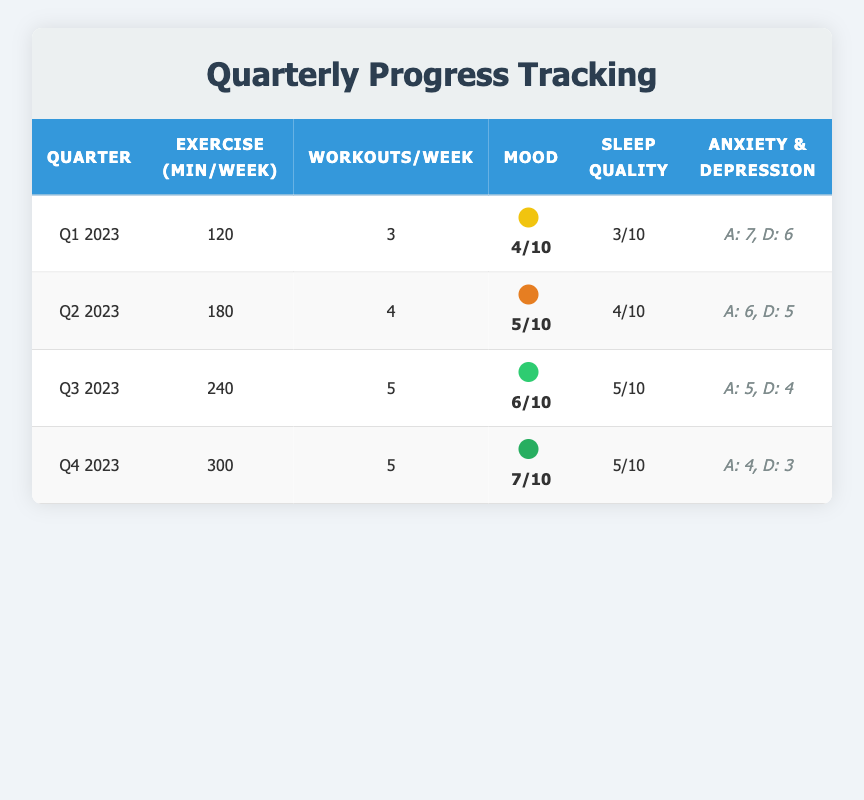What was the total number of exercise minutes recorded in Q3 2023? The table indicates that in Q3 2023, the exercise minutes were recorded as 240.
Answer: 240 How many workouts per week were done in Q1 2023? From the table, it shows that in Q1 2023, the workouts per week were recorded as 3.
Answer: 3 What is the change in average mood rating from Q1 to Q4 2023? In Q1 2023, the average mood rating was 4, and in Q4 2023, it was 7. The change is calculated as 7 - 4 = 3.
Answer: 3 Did the anxiety level decrease from Q1 2023 to Q4 2023? The anxiety level in Q1 2023 was 7, and in Q4 2023, it was 4. Since 4 is less than 7, the anxiety level did decrease.
Answer: Yes What is the average sleep quality rating across all quarters? The sleep quality ratings are 3, 4, 5, and 5 for Q1, Q2, Q3, and Q4 respectively. Sum them: 3 + 4 + 5 + 5 = 17. There are 4 quarters, so the average is 17/4 = 4.25.
Answer: 4.25 Which quarter had the highest recorded exercise minutes and what was that value? The highest exercise minutes are recorded in Q4 2023 with a value of 300 minutes, higher than other quarters.
Answer: Q4 2023: 300 How many total workouts were completed in Q2 and Q3 combined? In Q2 2023, there were 4 workouts per week, and in Q3 2023 there were 5 workouts per week. Assuming each quarter has approximately 13 weeks, the total workouts are (4 workouts/week * 13 weeks) + (5 workouts/week * 13 weeks) = 52 + 65 = 117.
Answer: 117 Was there an improvement in sleep quality from Q1 to Q3 2023? In Q1 2023, the sleep quality rating was 3, and in Q3 2023, it was 5. Since 5 is greater than 3, it indicates an improvement in sleep quality.
Answer: Yes What is the relationship between exercise minutes and average mood rating from Q2 to Q4 2023? In Q2 2023, exercise minutes were 180 with a mood rating of 5; in Q3, they were 240 with a rating of 6; in Q4, they were 300 with a rating of 7. The trend shows that as exercise minutes increase, the average mood rating also increases: (180 mins, 5) → (240 mins, 6) → (300 mins, 7).
Answer: Positive relationship 